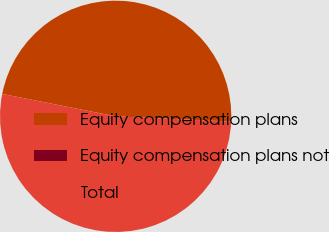Convert chart to OTSL. <chart><loc_0><loc_0><loc_500><loc_500><pie_chart><fcel>Equity compensation plans<fcel>Equity compensation plans not<fcel>Total<nl><fcel>47.62%<fcel>0.0%<fcel>52.38%<nl></chart> 